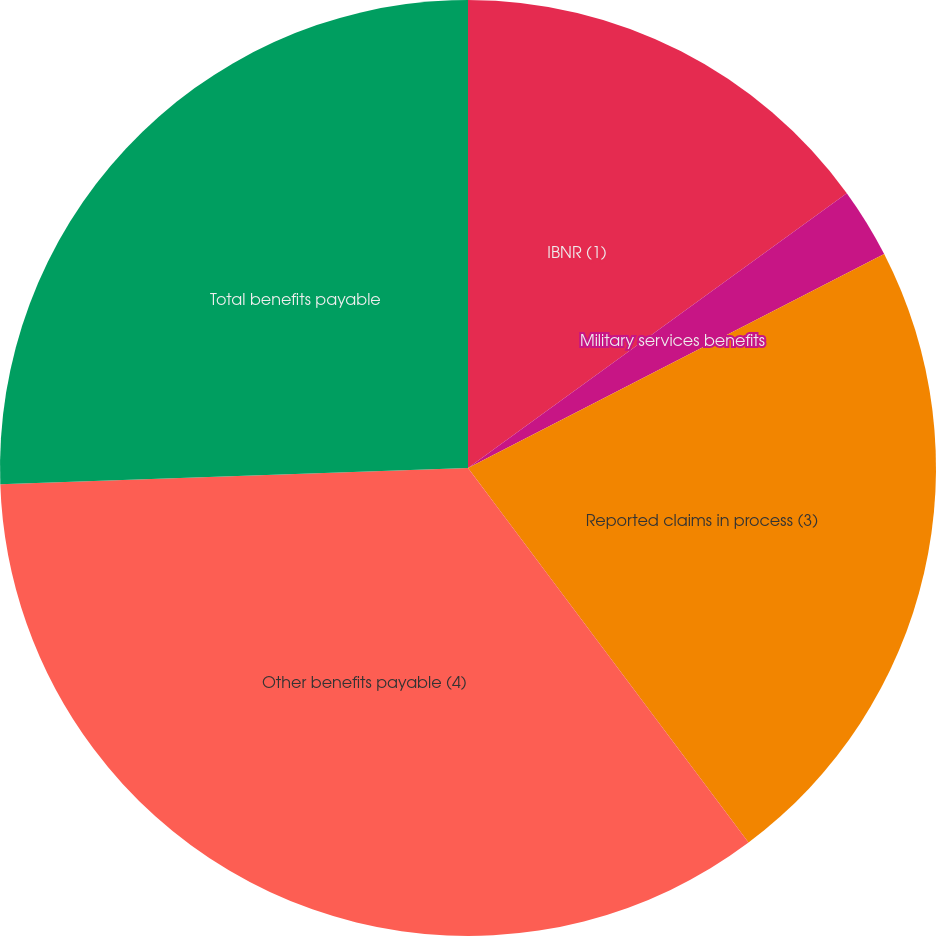Convert chart. <chart><loc_0><loc_0><loc_500><loc_500><pie_chart><fcel>IBNR (1)<fcel>Military services benefits<fcel>Reported claims in process (3)<fcel>Other benefits payable (4)<fcel>Total benefits payable<nl><fcel>15.01%<fcel>2.43%<fcel>22.33%<fcel>34.68%<fcel>25.55%<nl></chart> 